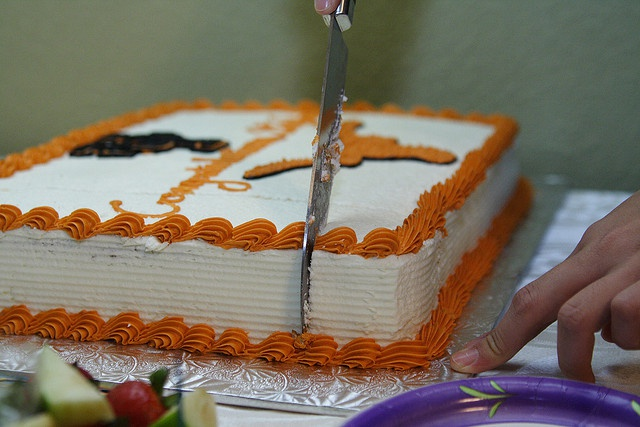Describe the objects in this image and their specific colors. I can see cake in gray, darkgray, brown, lightgray, and maroon tones, people in gray, brown, maroon, and black tones, and knife in gray, black, and darkgray tones in this image. 